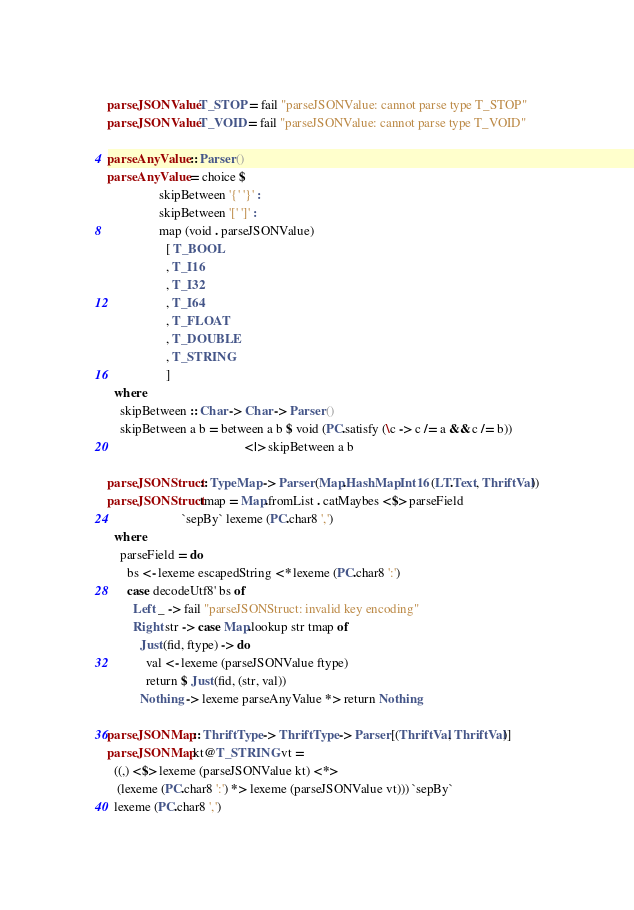<code> <loc_0><loc_0><loc_500><loc_500><_Haskell_>parseJSONValue T_STOP = fail "parseJSONValue: cannot parse type T_STOP"
parseJSONValue T_VOID = fail "parseJSONValue: cannot parse type T_VOID"

parseAnyValue :: Parser ()
parseAnyValue = choice $
                skipBetween '{' '}' :
                skipBetween '[' ']' :
                map (void . parseJSONValue)
                  [ T_BOOL
                  , T_I16
                  , T_I32
                  , T_I64
                  , T_FLOAT
                  , T_DOUBLE
                  , T_STRING
                  ]
  where
    skipBetween :: Char -> Char -> Parser ()
    skipBetween a b = between a b $ void (PC.satisfy (\c -> c /= a && c /= b))
                                          <|> skipBetween a b

parseJSONStruct :: TypeMap -> Parser (Map.HashMap Int16 (LT.Text, ThriftVal))
parseJSONStruct tmap = Map.fromList . catMaybes <$> parseField
                       `sepBy` lexeme (PC.char8 ',')
  where
    parseField = do
      bs <- lexeme escapedString <* lexeme (PC.char8 ':')
      case decodeUtf8' bs of
        Left _ -> fail "parseJSONStruct: invalid key encoding"
        Right str -> case Map.lookup str tmap of
          Just (fid, ftype) -> do
            val <- lexeme (parseJSONValue ftype)
            return $ Just (fid, (str, val))
          Nothing -> lexeme parseAnyValue *> return Nothing

parseJSONMap :: ThriftType -> ThriftType -> Parser [(ThriftVal, ThriftVal)]
parseJSONMap kt@T_STRING vt =
  ((,) <$> lexeme (parseJSONValue kt) <*>
   (lexeme (PC.char8 ':') *> lexeme (parseJSONValue vt))) `sepBy`
  lexeme (PC.char8 ',')</code> 